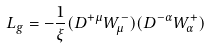Convert formula to latex. <formula><loc_0><loc_0><loc_500><loc_500>L _ { g } = - \frac { 1 } { \xi } ( D ^ { + \mu } W ^ { - } _ { \mu } ) ( D ^ { - \alpha } W ^ { + } _ { \alpha } )</formula> 